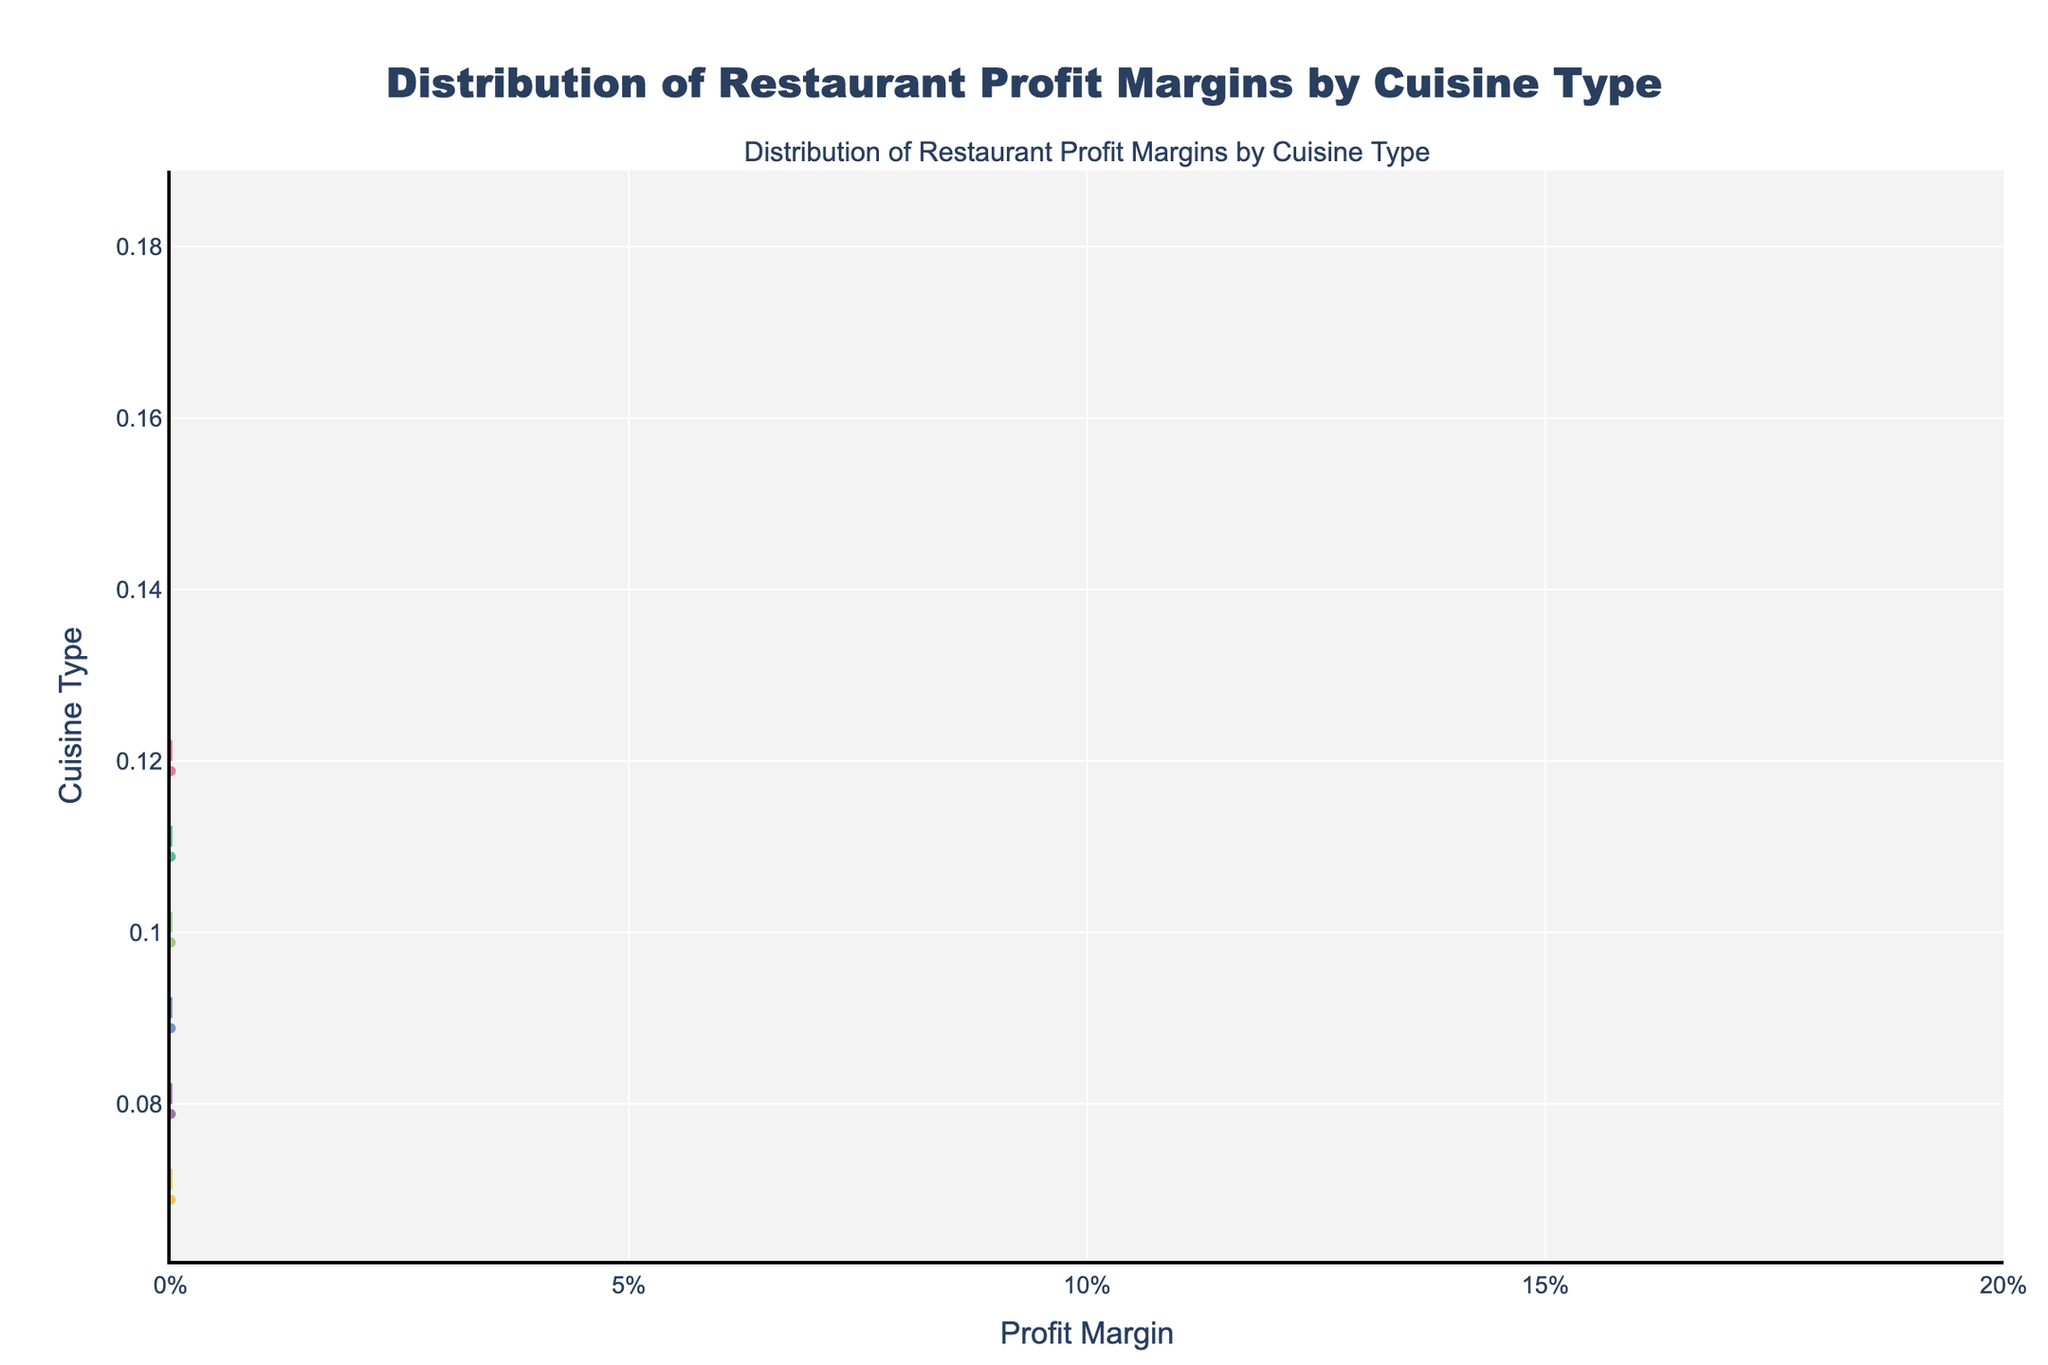What is the title of the figure? The title is usually found at the top of the figure and informs the reader about what the figure represents. Here, the title likely indicates the topic being visualized.
Answer: Distribution of Restaurant Profit Margins by Cuisine Type Which cuisine has the highest range of profit margins? To determine this, look for the cuisine type with the longest spread in the horizontal direction. This represents a wide range of profit margins.
Answer: Indian What is the overall range of profit margins in Italian cuisine? To find this, identify the minimum and maximum points on the horizontal axis for the Italian cuisine density plot and calculate the range.
Answer: 0.08 to 0.15 Which cuisine has the lowest mean profit margin? Mean profit margins are depicted with a visible mean line in each density plot. The lowest mean line identifies the cuisine with the lowest average profit margin.
Answer: American How does the profit margin distribution of Chinese cuisine compare to Mexican cuisine? Compare the central tendency and spread of the profit margin distributions for Chinese and Mexican cuisines by observing their density plots side by side. Note the ranges and average values.
Answer: Chinese distribution is slightly lower and less spread out than Mexican Which cuisine’s profit margins are most centered around their mean? The most centered distribution will have the highest density around the mean line with fewer points spread out. This indicates tight clustering around the central value.
Answer: French What can you infer about the variability of profit margins among different cuisine types? Look for how spread out the dots are around the mean lines. More spread indicates higher variability, while tightly clustered points indicate lower variability.
Answer: Indian and Mexican have high variability, while American is less variable What is the median profit margin for French cuisine? To find the median, look at the point where half the data points are on each side. This is usually close to the densest part of the plot for French cuisine.
Answer: 0.14 How do Italian and Indian cuisines compare in terms of profit margin variability? For variability, observe the spread of data points. A more spread out distribution indicates higher variability. Compare the spreads of Italian and Indian cuisines.
Answer: Indian has higher variability than Italian What insights can be derived from the distribution of profit margins for potential investors? Investors might look for cuisines with higher average profit margins and lower variability. Considering distributions can help identify stable and profitable investment opportunities.
Answer: Indian and French cuisines seem most promising for high margins 